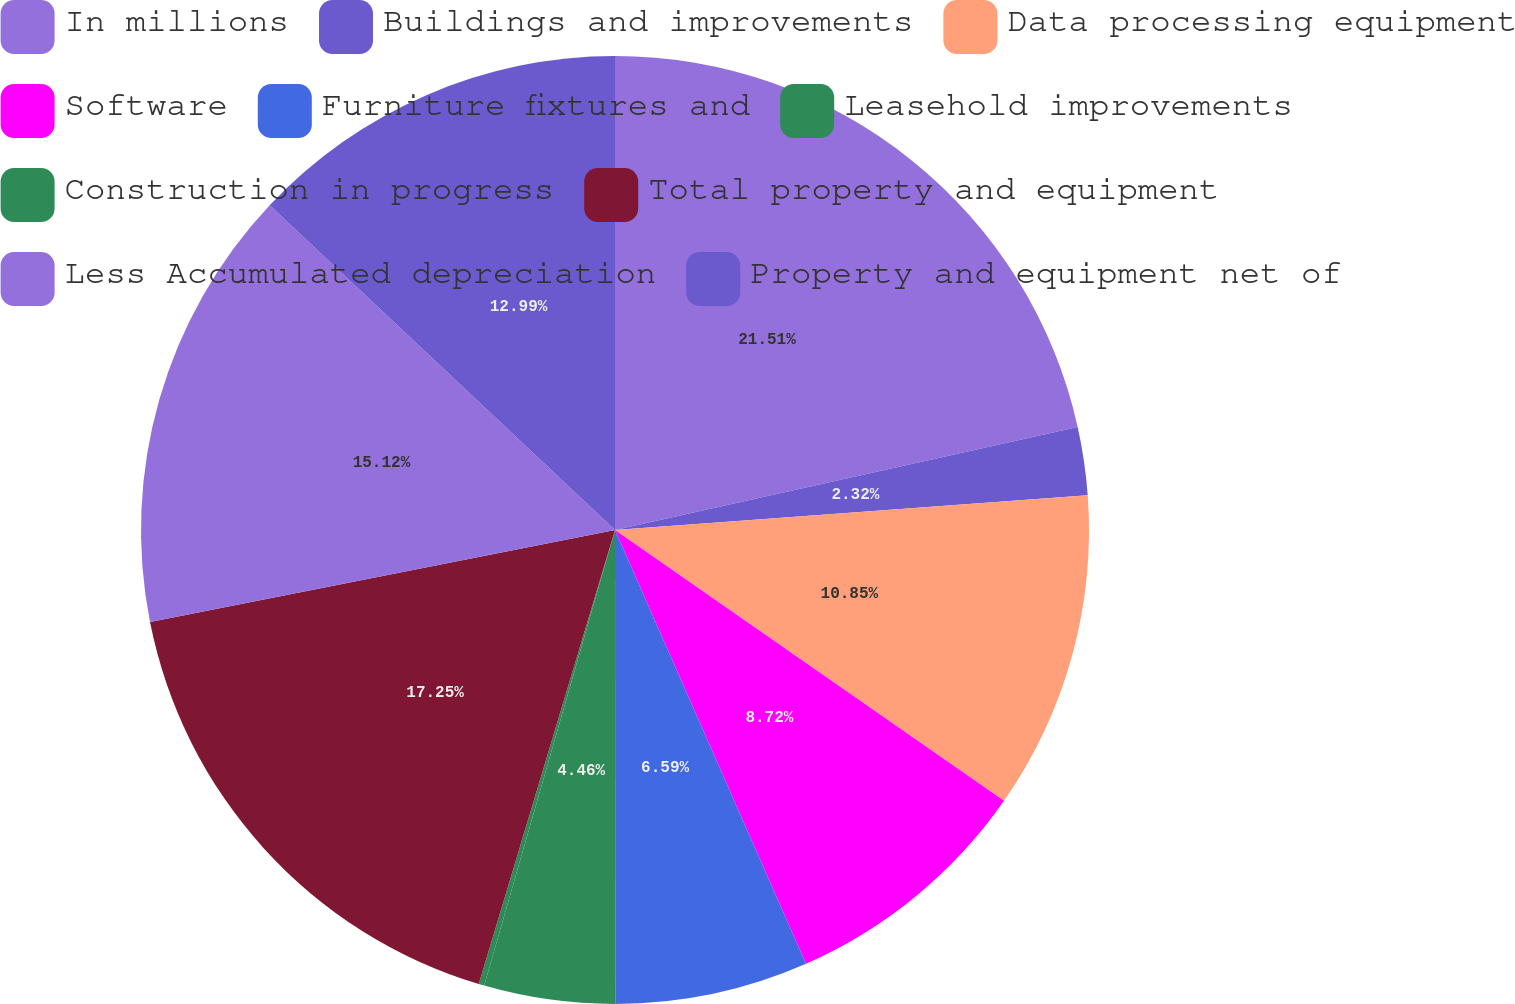Convert chart. <chart><loc_0><loc_0><loc_500><loc_500><pie_chart><fcel>In millions<fcel>Buildings and improvements<fcel>Data processing equipment<fcel>Software<fcel>Furniture fixtures and<fcel>Leasehold improvements<fcel>Construction in progress<fcel>Total property and equipment<fcel>Less Accumulated depreciation<fcel>Property and equipment net of<nl><fcel>21.51%<fcel>2.32%<fcel>10.85%<fcel>8.72%<fcel>6.59%<fcel>4.46%<fcel>0.19%<fcel>17.25%<fcel>15.12%<fcel>12.99%<nl></chart> 